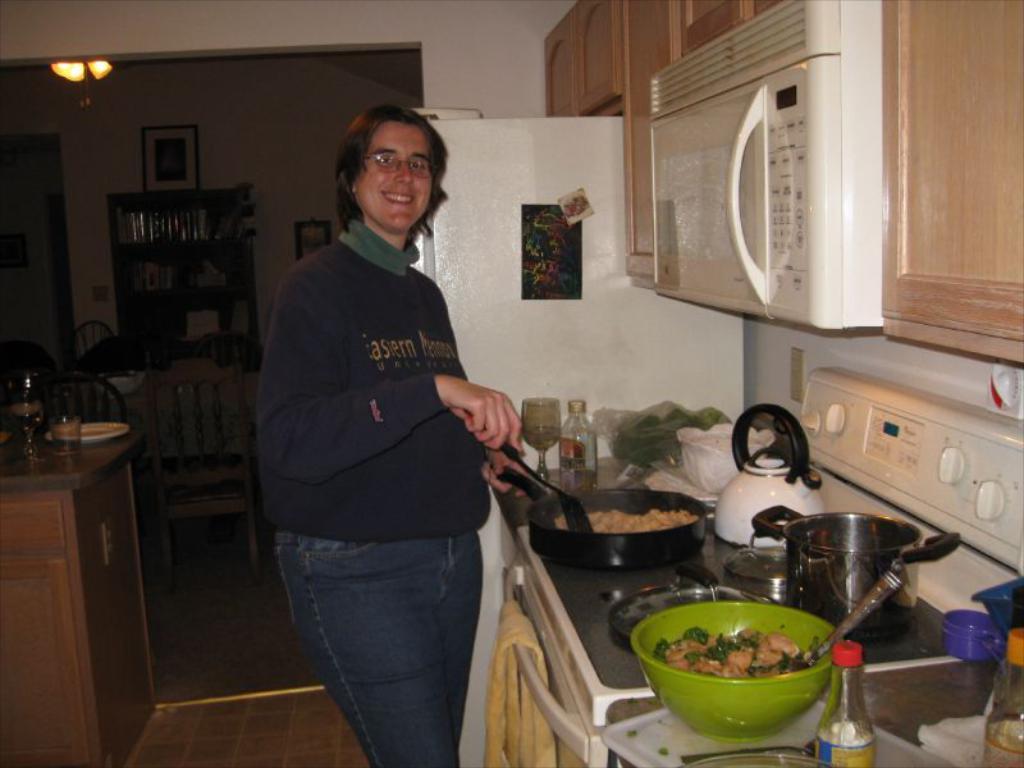What does the person's sweater say?
Give a very brief answer. Unanswerable. 